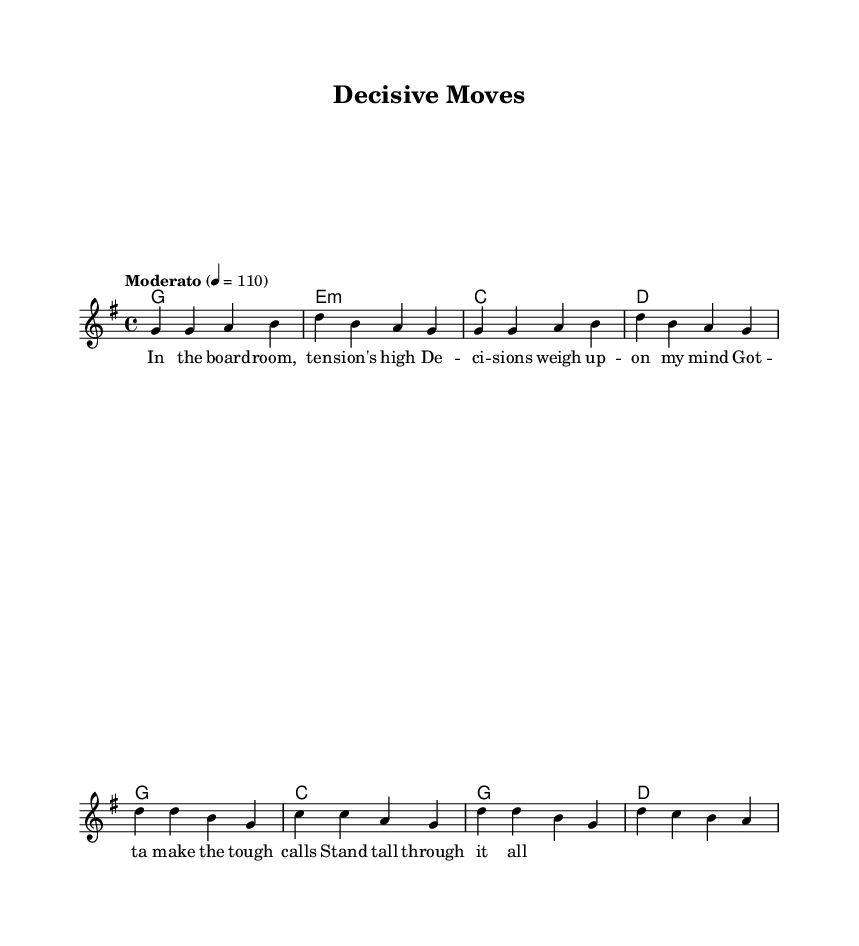What is the key signature of this music? The key signature is G major, which has one sharp (F#). This can be determined by looking at the key context that defines the tonality of the piece.
Answer: G major What is the time signature of the piece? The time signature is 4/4, indicated at the start of the piece. This means there are four beats in each measure and the quarter note gets one beat.
Answer: 4/4 What is the tempo marking for this piece? The tempo marking is "Moderato," with a metronome marking of 110 beats per minute, as specified in the global music settings.
Answer: Moderato How many measures are in the verse section? The verse section contains eight measures, which can be determined by counting each group of notes separated by vertical lines.
Answer: Eight What is the primary theme of the lyrics? The primary theme of the lyrics revolves around decision-making in high-pressure scenarios, particularly in a leadership context. The sentiments expressed focus on making tough calls and remaining resilient.
Answer: Leadership What are the chord types used in the harmonies section? The harmonies section includes major and minor chords, specifically G major, E minor, C major, and D major. The major chords typically provide a resolved sound, while the minor chords add a touch of tension that aligns with the lyrical themes.
Answer: Major and minor How does the chorus differ from the verse in musical structure? The chorus features a different melodic contour and is often more repetitive, creating a contrasting yet familiar structure to the verse. It serves to emphasize the main message of resilience. This can be noted by comparing the unique melodic phrases and lyrical content in both sections.
Answer: Repetitive and contrasting 